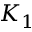<formula> <loc_0><loc_0><loc_500><loc_500>K _ { 1 }</formula> 